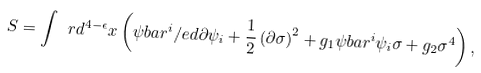<formula> <loc_0><loc_0><loc_500><loc_500>S = \int \ r d ^ { 4 - \epsilon } x \left ( \psi b a r ^ { i } \slash e d { \partial } \psi _ { i } + \frac { 1 } { 2 } \left ( \partial \sigma \right ) ^ { 2 } + g _ { 1 } \psi b a r ^ { i } \psi _ { i } \sigma + g _ { 2 } \sigma ^ { 4 } \right ) ,</formula> 